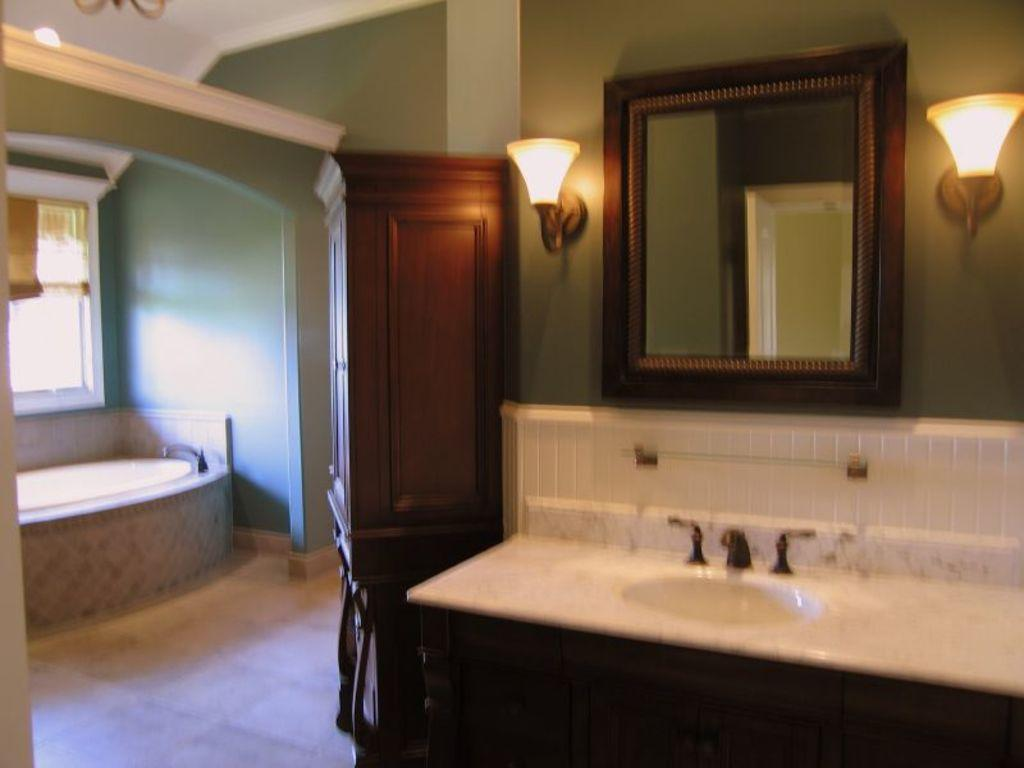What is the main object in the image? There is a wash basin in the image. What can be seen in the background of the image? There is a mirror, lights, a door, a bathtub, a window, and a wall in the image. What type of room might this image be taken in? The image is likely taken in a room, possibly a bathroom. What type of pen is being used to write on the wall in the image? There is no pen or writing on the wall in the image. What type of plants can be seen growing near the bathtub in the image? There are no plants visible in the image. 